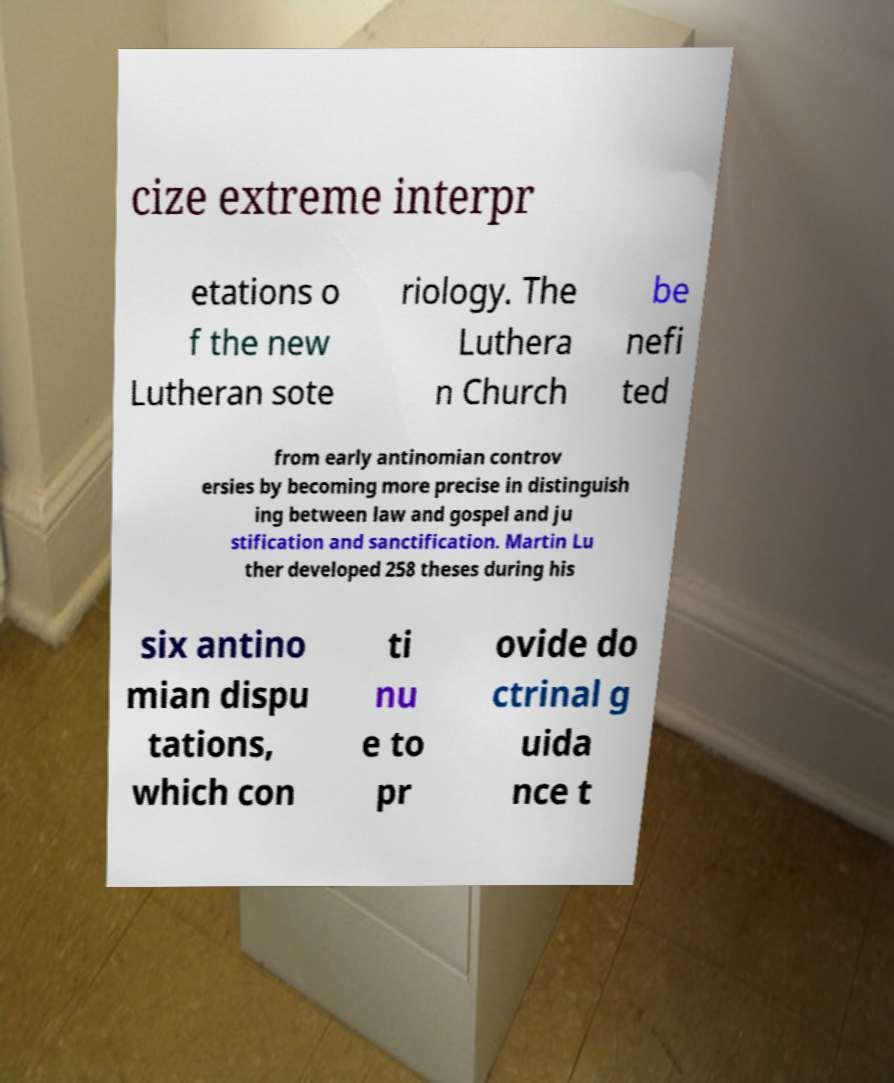Please read and relay the text visible in this image. What does it say? cize extreme interpr etations o f the new Lutheran sote riology. The Luthera n Church be nefi ted from early antinomian controv ersies by becoming more precise in distinguish ing between law and gospel and ju stification and sanctification. Martin Lu ther developed 258 theses during his six antino mian dispu tations, which con ti nu e to pr ovide do ctrinal g uida nce t 